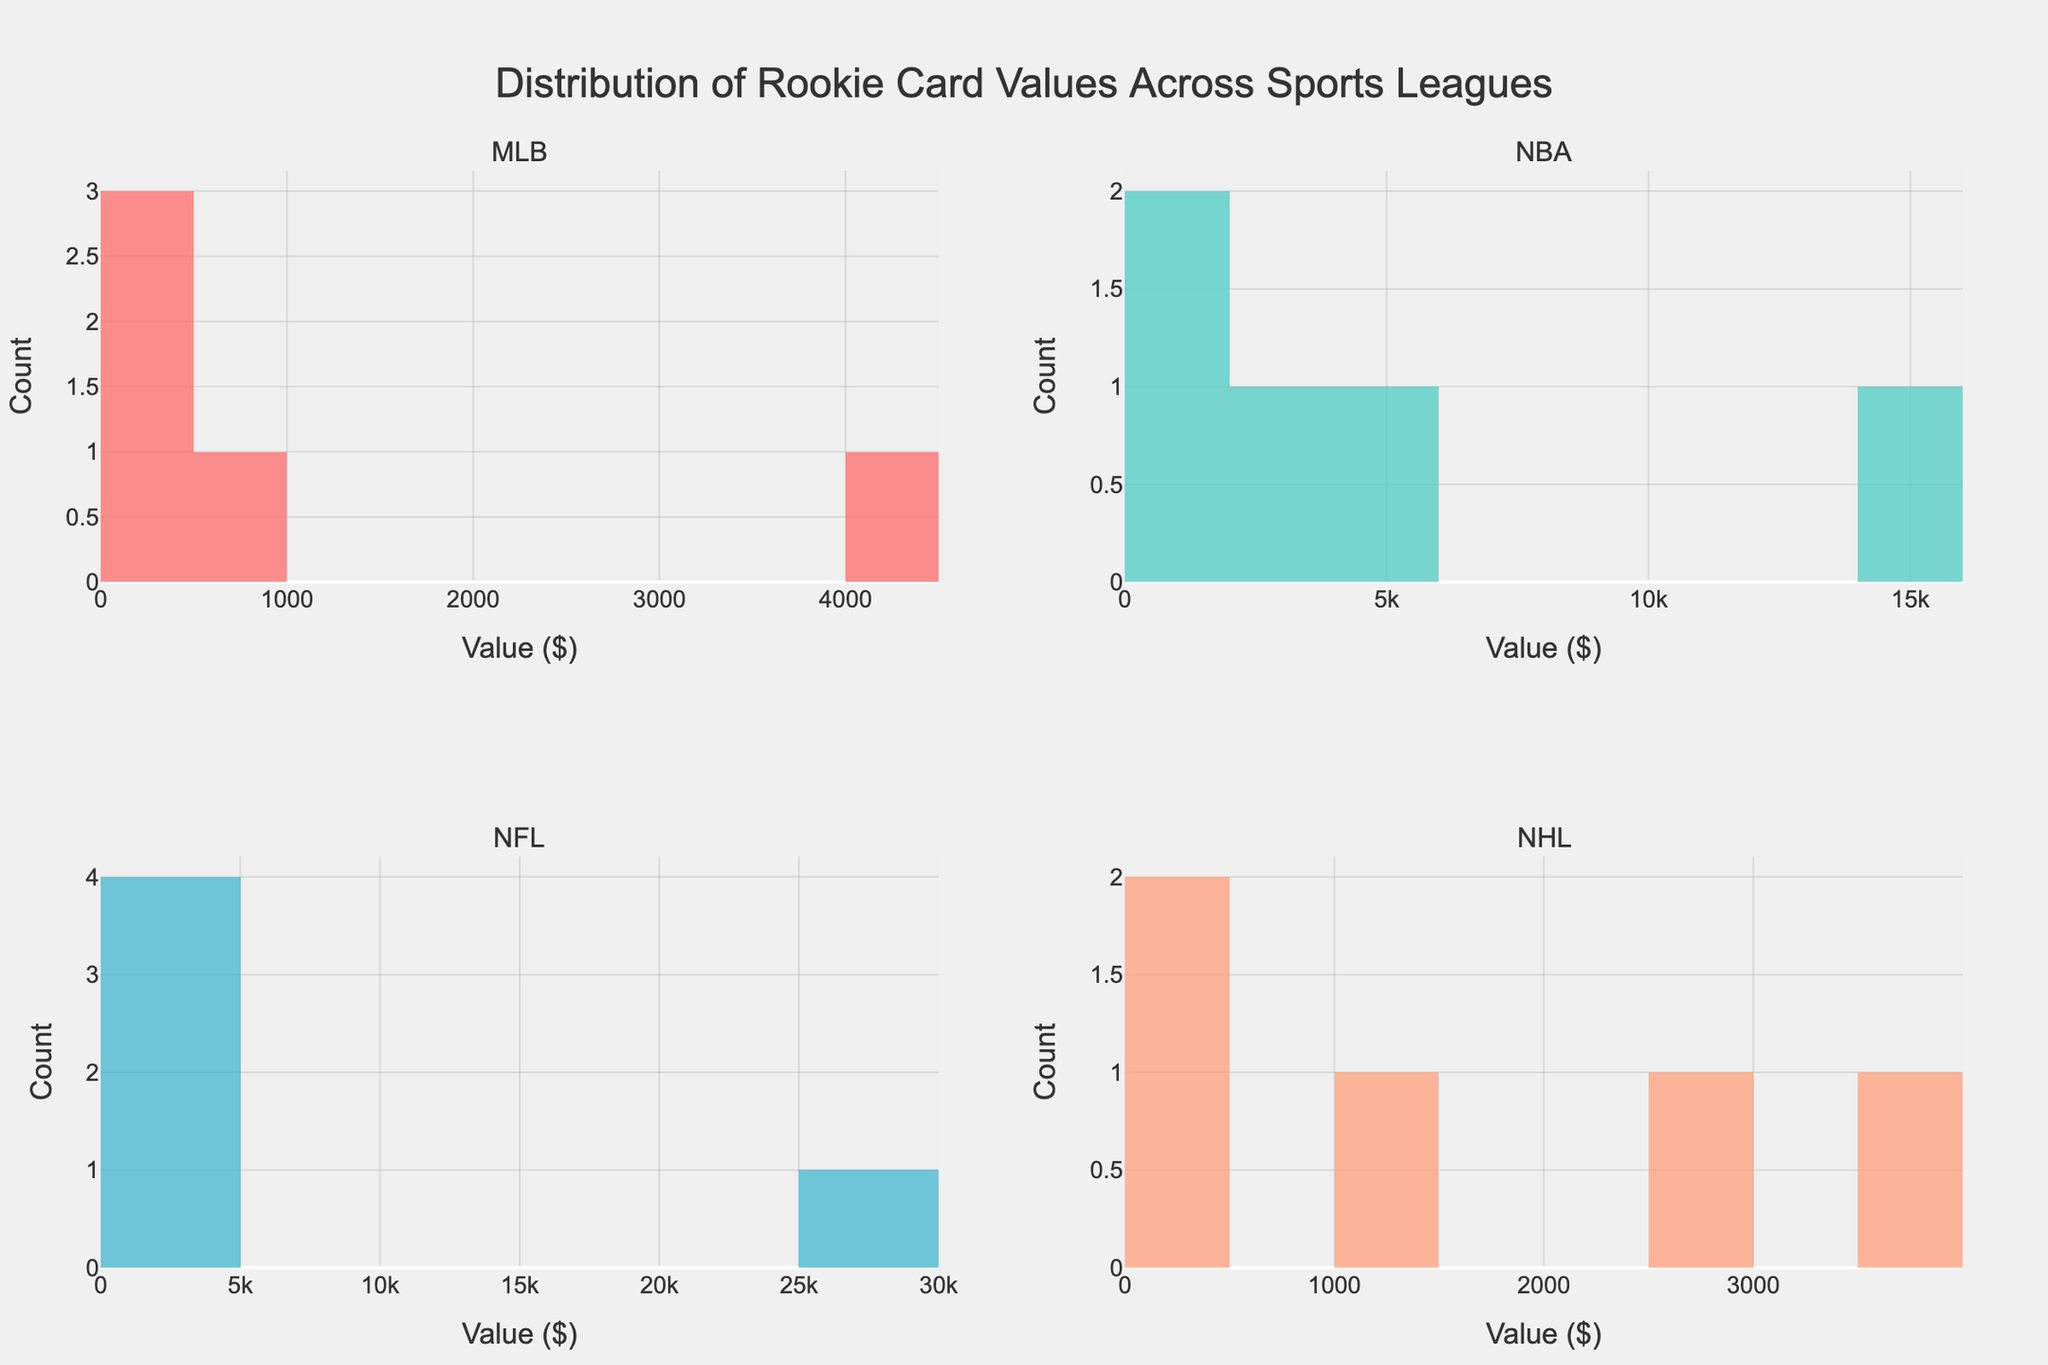What is the title of the figure? The title is typically at the top and gives a summary of what the figure is about. In this case, it addresses the distribution of values across different sports leagues.
Answer: Distribution of Rookie Card Values Across Sports Leagues How many subplots are in the figure? Subplots are individual graphs within the main plot. This specific figure is divided into multiple smaller plots for different leagues.
Answer: 4 Which league has the highest rookie card value? You can determine this by looking at the histogram with the highest bins at the extreme right, indicating the highest card value.
Answer: NFL What value range do most NBA rookie cards fall into? By observing the bins in the NBA subplot, you can determine where the majority of the data points (rookie card values) are grouped.
Answer: $0 - $5000 Which league has the most evenly distributed rookie card values? To find the most evenly distributed values, observe which histogram has a relatively balanced spread across its bins, indicating that no single dollar range is overly dominant.
Answer: MLB Compare the highest valued rookie card in the MLB and NBA. Which one is higher? Look at the far-right bins in both MLB and NBA subplots to see the maximum values in each league's histogram. Calculate or directly compare the highest bars.
Answer: NBA Which rookie card shown in the NFL subplot has a value less than $1000? Refer to the bins in the NFL subplot and identify any bars within the value range below $1000. Compare with individual card values if needed.
Answer: Lamar Jackson ($350), Justin Herbert ($280), Joe Burrow ($200) What is the common highest value bin across all leagues? Observe the highest bins in each subplot to see if there is a common dollar range that appears as a peak in all histograms, indicating a frequent occurrence.
Answer: There is no common highest value bin across all leagues How does the value distribution in the NHL compare to the NBA? Compare the spread and height of the bins in the NHL and NBA subplots. Look for differences in the concentration of values and the range spread.
Answer: NBA has a wider spread and higher peaks Which histogram suggests that a single card has an extremely high value compared to the rest? Find which histogram has a single, very high bin compared to the rest, indicating one card of much higher value than the others.
Answer: NFL (Tom Brady's card value) 